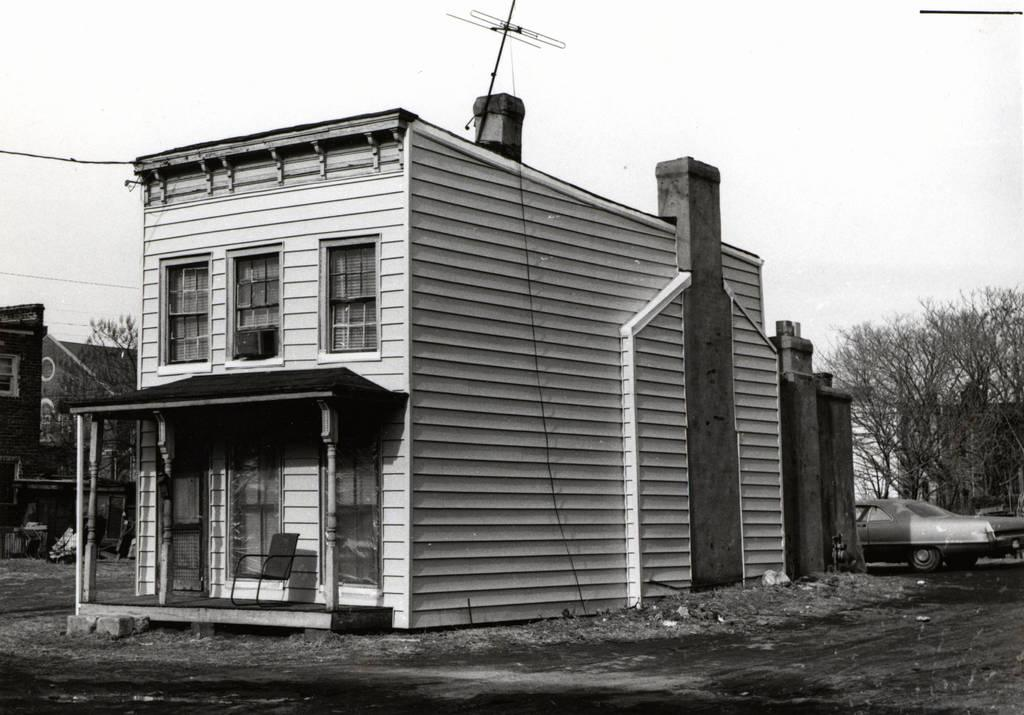What type of structures can be seen in the image? There are houses in the image. What mode of transportation is visible in the image? There is a car in the image. What type of vegetation is present in the image? There are trees in the image. What object is sticking up from one of the houses or structures? There is an antenna in the image. What type of offer is being made by the car in the image? There is no indication in the image that the car is making any offer. On which side of the car is the offer being presented? As there is no offer being made by the car, there is no side to consider. 